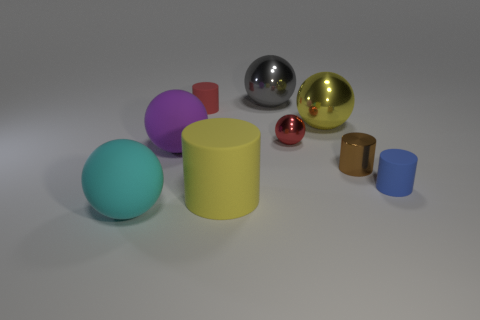Subtract all tiny red spheres. How many spheres are left? 4 Subtract 5 spheres. How many spheres are left? 0 Add 1 blue metallic cylinders. How many objects exist? 10 Subtract all purple balls. How many balls are left? 4 Subtract all purple cylinders. Subtract all cyan spheres. How many cylinders are left? 4 Subtract all green cubes. How many gray cylinders are left? 0 Subtract 0 cyan cylinders. How many objects are left? 9 Subtract all cylinders. How many objects are left? 5 Subtract all small green balls. Subtract all balls. How many objects are left? 4 Add 8 large yellow things. How many large yellow things are left? 10 